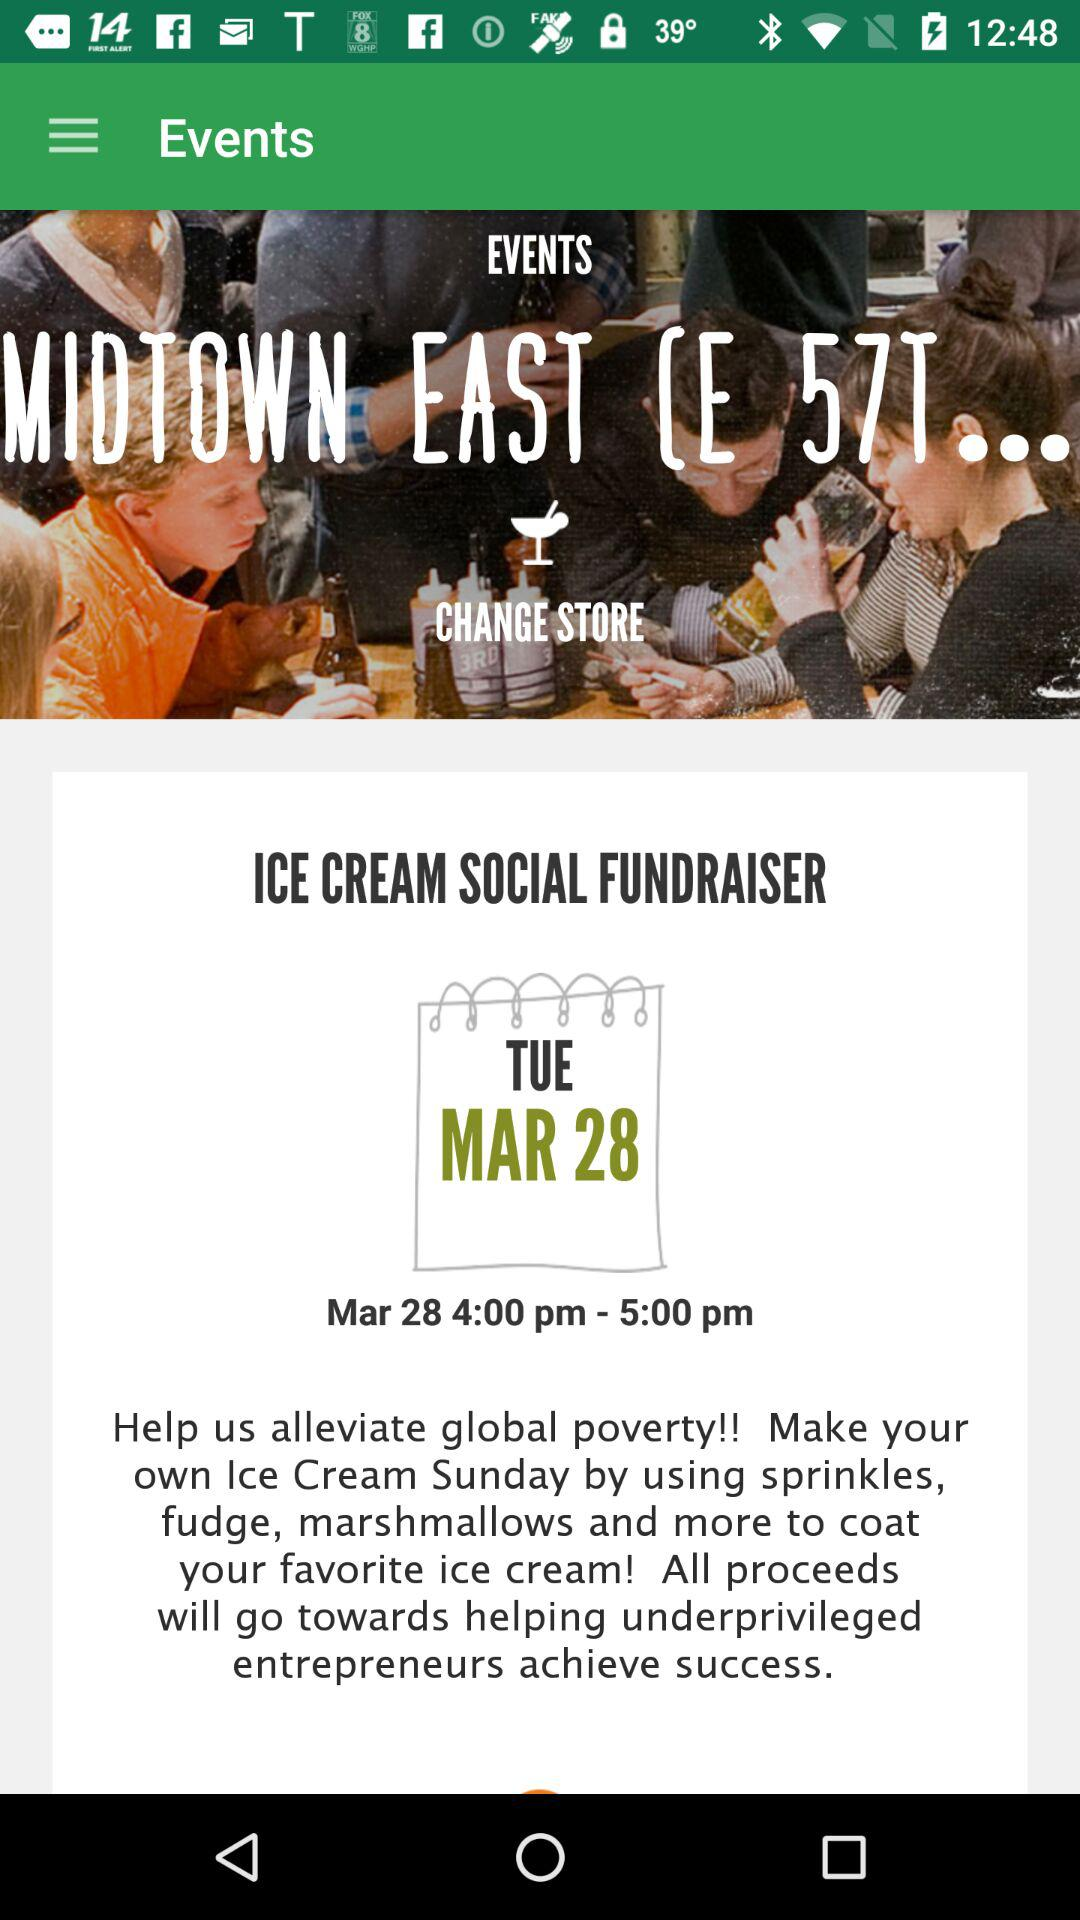For what day is the event schedule? The event is scheduled for Tuesday. 